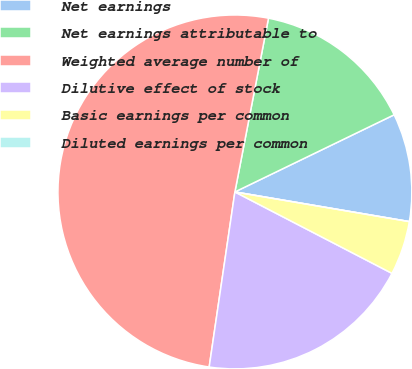Convert chart. <chart><loc_0><loc_0><loc_500><loc_500><pie_chart><fcel>Net earnings<fcel>Net earnings attributable to<fcel>Weighted average number of<fcel>Dilutive effect of stock<fcel>Basic earnings per common<fcel>Diluted earnings per common<nl><fcel>9.86%<fcel>14.78%<fcel>50.72%<fcel>19.71%<fcel>4.93%<fcel>0.0%<nl></chart> 